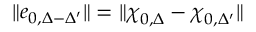Convert formula to latex. <formula><loc_0><loc_0><loc_500><loc_500>\| e _ { 0 , \Delta - \Delta ^ { \prime } } \| = \| \chi _ { 0 , \Delta } - \chi _ { 0 , \Delta ^ { \prime } } \|</formula> 